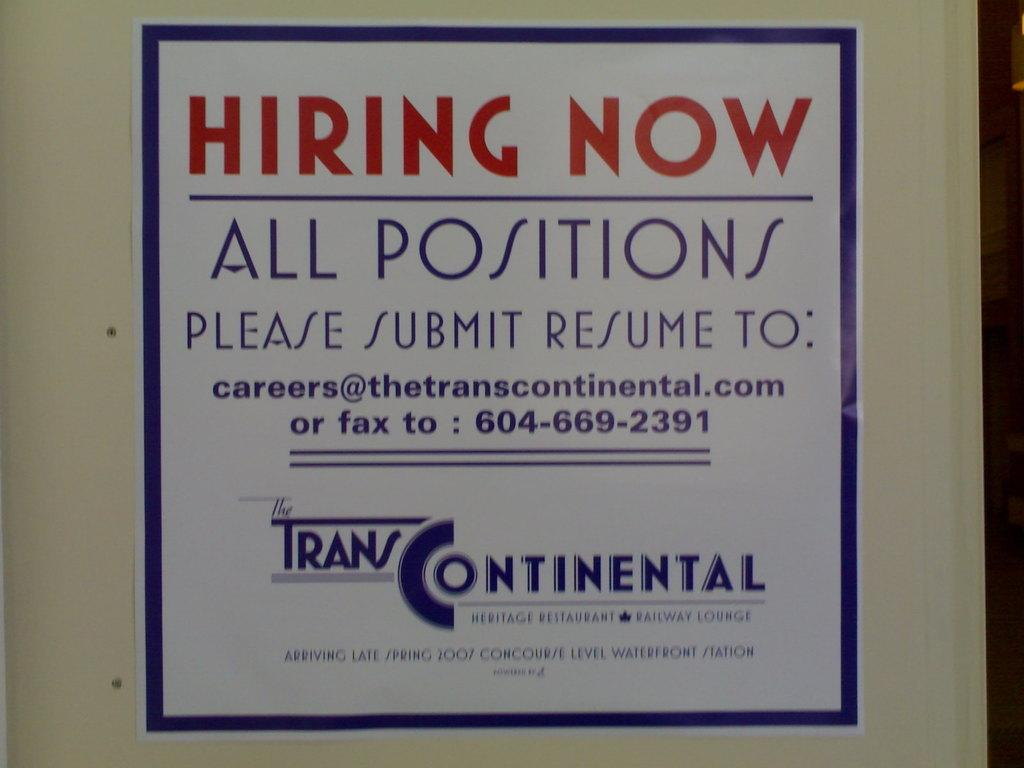<image>
Provide a brief description of the given image. A poster for Trans Continental shows that they are "hiring now." 